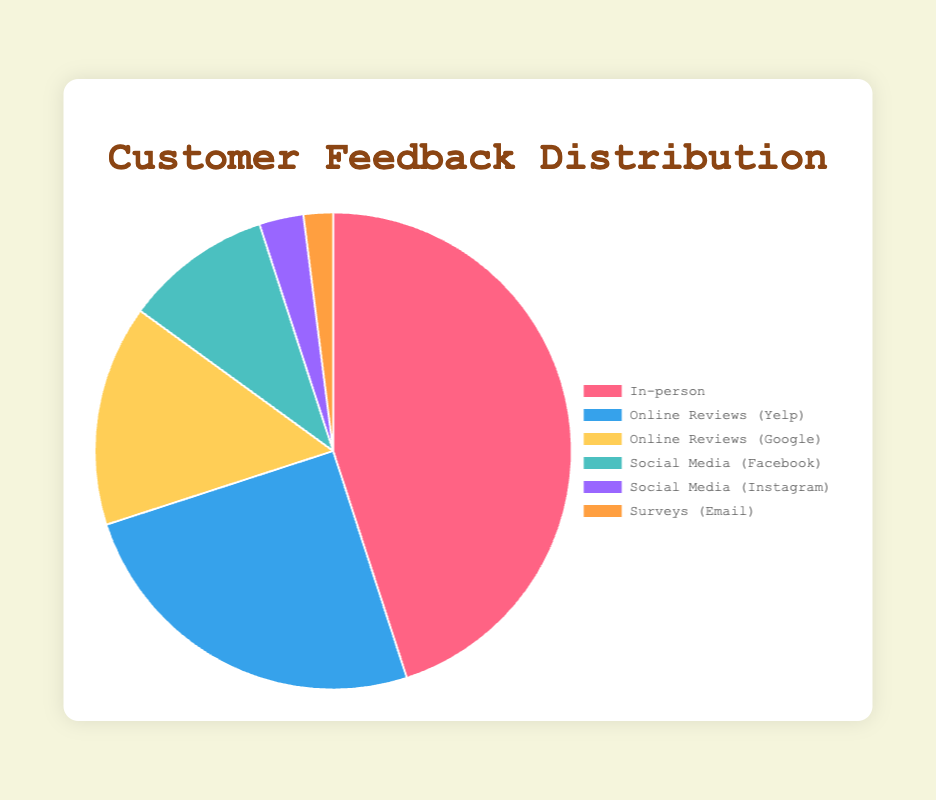What source provides the highest percentage of customer feedback? The maximum value in the chart is represented by the source with the highest percentage. By looking at the pie chart, the percentage of feedback from 'In-person' is the highest at 45%.
Answer: In-person What is the total percentage of feedback received from "Online Reviews (Yelp)" and "Online Reviews (Google)" combined? To find the total percentage from both sources, sum the percentages given: 25% from Yelp and 15% from Google. So, 25 + 15 = 40.
Answer: 40% Which source provides less feedback, "Social Media (Instagram)" or "Surveys (Email)"? Compare the two given percentages for Instagram and Email Surveys. Instagram has a percentage of 3%, whereas Email Surveys have 2%. Since 2% is less than 3%, Surveys provide less feedback.
Answer: Surveys (Email) How much greater is the percentage of "In-person" feedback compared to "Social Media (Facebook)" feedback? Subtract the percentage of Facebook feedback from the percentage of In-person feedback: 45% - 10% = 35%.
Answer: 35% What is the total percentage for all sources except "In-person"? Sum up the percentages for all feedback sources except In-person: 25% (Yelp) + 15% (Google) + 10% (Facebook) + 3% (Instagram) + 2% (Email) = 55%.
Answer: 55% Which source has the smallest percentage of feedback and what is its percentage? The smallest value in the pie chart indicates the source with the least feedback. 'Surveys (Email)' has the smallest percentage at 2%.
Answer: Surveys (Email), 2% What is the average percentage of feedback for "Social Media (Facebook)" and "Social Media (Instagram)"? To find the average, sum the percentages of Facebook and Instagram feedback and then divide by 2. (10% + 3%) / 2 = 6.5%.
Answer: 6.5% Which sources contribute to a combined percentage of 50% or more? Add the top contributing percentages until the sum reaches or exceeds 50%: In-person (45%) + Yelp (25%) = 70%. Both In-person and Yelp together contribute more than 50%.
Answer: In-person, Online Reviews (Yelp) How much more feedback is received through "In-person" than through all other sources combined? First, calculate the total feedback from all other sources combined: 25% (Yelp) + 15% (Google) + 10% (Facebook) + 3% (Instagram) + 2% (Email) = 55%. The percentage received through "In-person" is 45%, so the difference is 45% - 55% = -10%. (In-person receives 10% less than all others combined.)
Answer: 10% less 